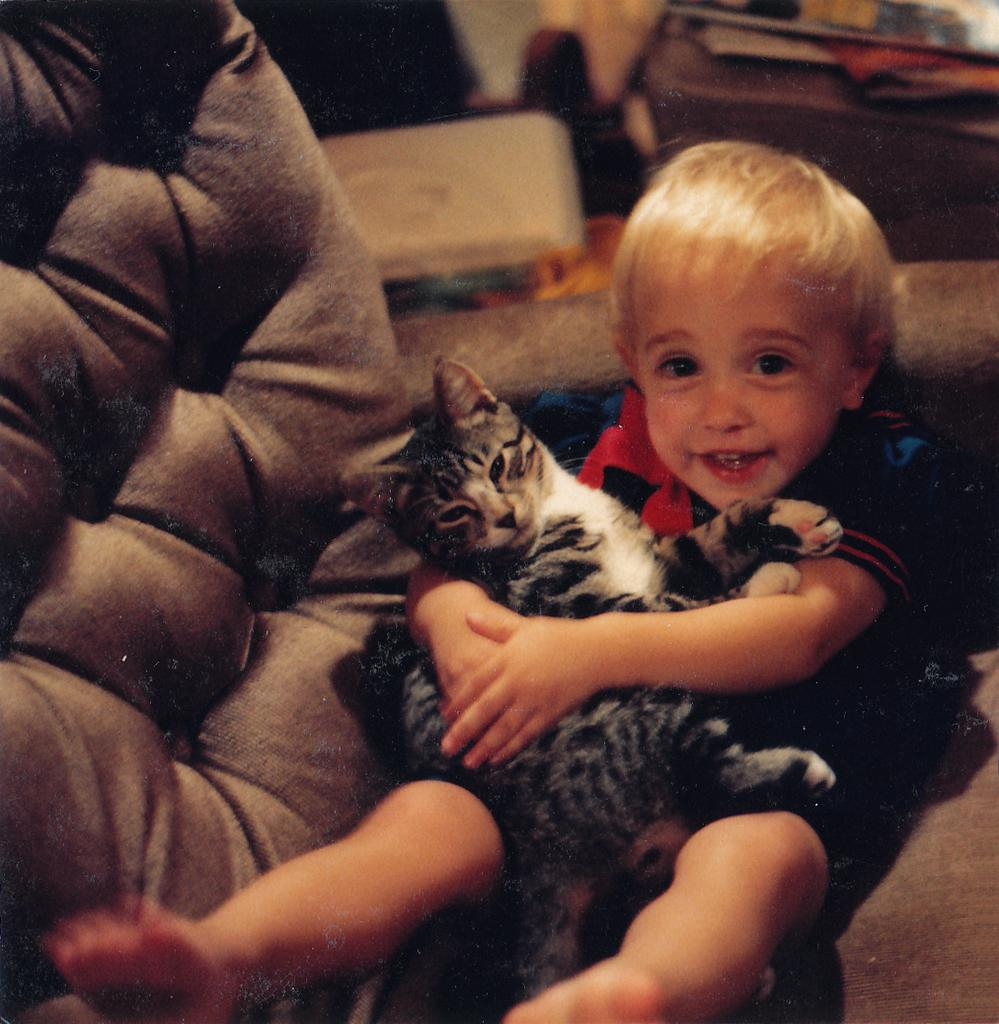What is the main subject in the foreground of the image? There is a boy in the foreground of the image. What is the boy doing in the image? The boy is sitting on a chair in the image. What is the boy holding in the image? The boy is holding a cat in the image. What can be seen at the top of the image? There are objects visible at the top of the image. What type of loaf is the boy eating in the image? There is no loaf present in the image; the boy is holding a cat. Can you tell me how many credits the boy has earned in the image? There is no mention of credits or any educational context in the image; it simply shows a boy holding a cat. 